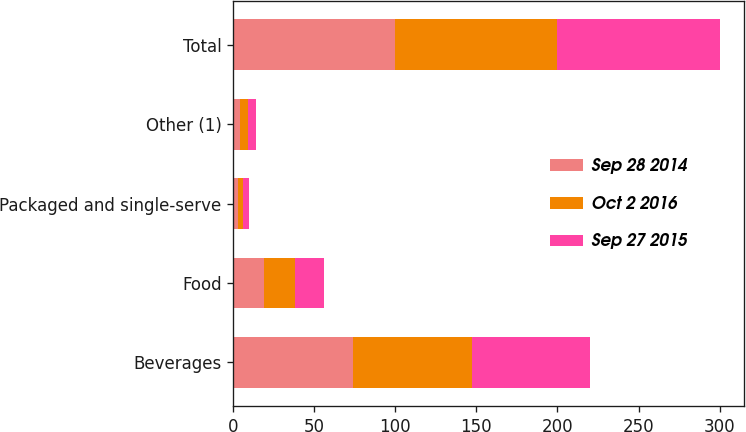Convert chart to OTSL. <chart><loc_0><loc_0><loc_500><loc_500><stacked_bar_chart><ecel><fcel>Beverages<fcel>Food<fcel>Packaged and single-serve<fcel>Other (1)<fcel>Total<nl><fcel>Sep 28 2014<fcel>74<fcel>19<fcel>3<fcel>4<fcel>100<nl><fcel>Oct 2 2016<fcel>73<fcel>19<fcel>3<fcel>5<fcel>100<nl><fcel>Sep 27 2015<fcel>73<fcel>18<fcel>4<fcel>5<fcel>100<nl></chart> 